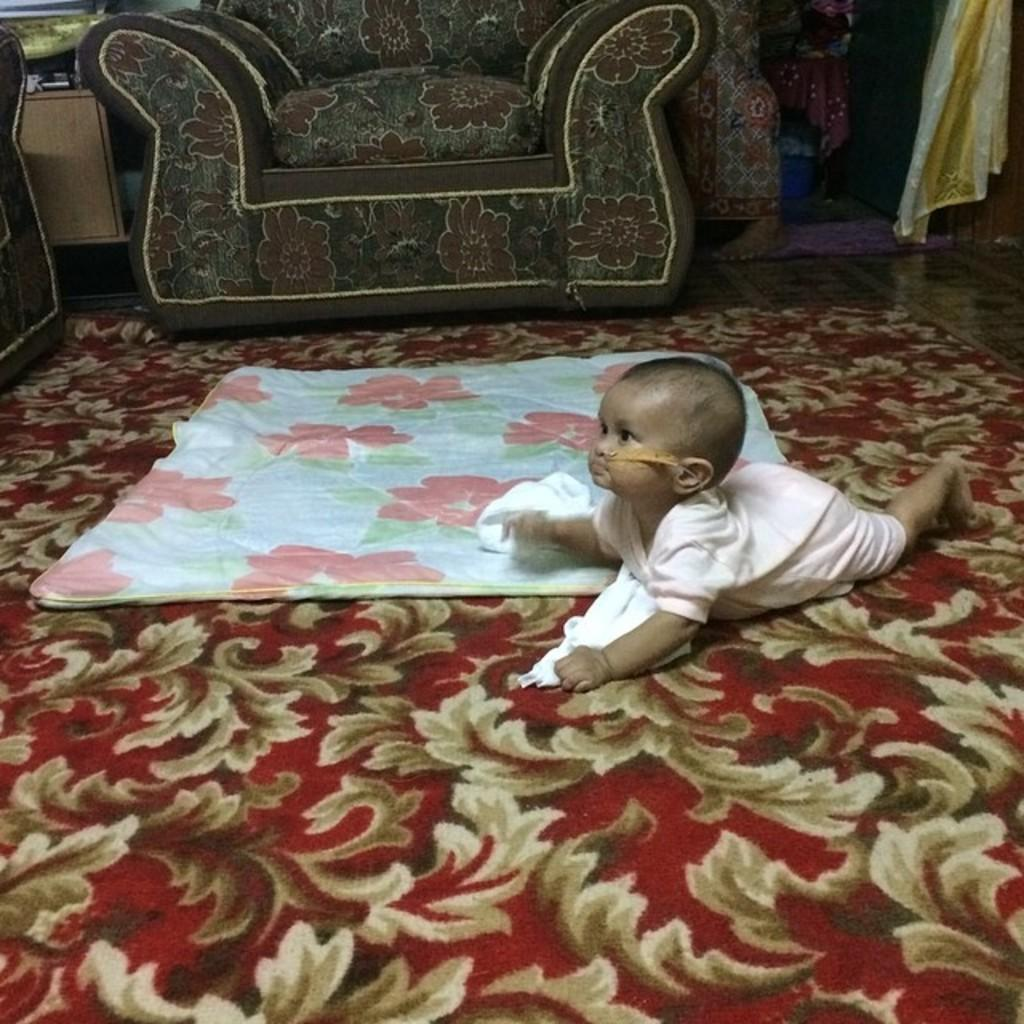What is the main subject of the image? There is a baby in the image. What is the baby wearing? The baby is wearing a pink dress. What is the baby doing in the image? The baby is crawling on the floor. What is present on the floor to provide comfort or safety? There is a floor mat in the image. Where is the baby likely to sleep? There is a baby bed in the image, which suggests that is where the baby sleeps. What can be seen in the background of the image? There is a couch and clothes visible in the background of the image. How many boats are visible in the image? There are no boats present in the image. What type of exchange is taking place between the baby and the couch? There is no exchange taking place between the baby and the couch; the baby is crawling on the floor, and the couch is in the background. 